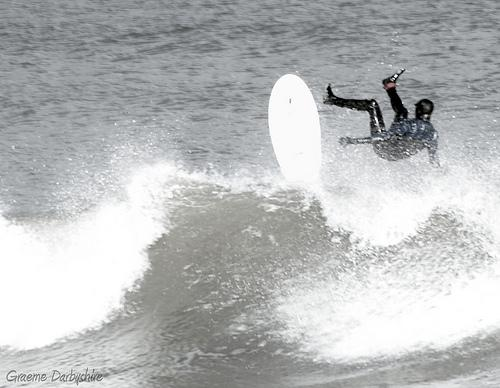Question: what just happened to the surfer?
Choices:
A. He is resting.
B. He is sleeping.
C. He is running.
D. He fell.
Answer with the letter. Answer: D Question: who just fell?
Choices:
A. The girl.
B. The surfer.
C. The skater.
D. The bike rider.
Answer with the letter. Answer: B Question: where is the surfer?
Choices:
A. On the beach.
B. On the sidewalk.
C. In the ocean.
D. On the bench.
Answer with the letter. Answer: C Question: what color are the wave peaks?
Choices:
A. Red.
B. Blue.
C. Pink.
D. White.
Answer with the letter. Answer: D Question: where is the surfboard?
Choices:
A. The ocean.
B. On the sand.
C. Leaning on the fence.
D. On the bench.
Answer with the letter. Answer: A 